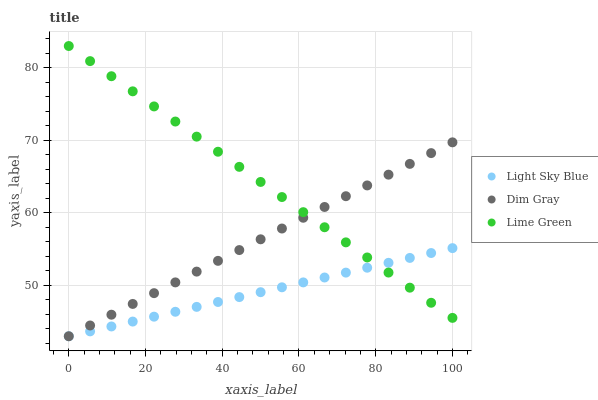Does Light Sky Blue have the minimum area under the curve?
Answer yes or no. Yes. Does Lime Green have the maximum area under the curve?
Answer yes or no. Yes. Does Lime Green have the minimum area under the curve?
Answer yes or no. No. Does Light Sky Blue have the maximum area under the curve?
Answer yes or no. No. Is Dim Gray the smoothest?
Answer yes or no. Yes. Is Lime Green the roughest?
Answer yes or no. Yes. Is Light Sky Blue the smoothest?
Answer yes or no. No. Is Light Sky Blue the roughest?
Answer yes or no. No. Does Dim Gray have the lowest value?
Answer yes or no. Yes. Does Lime Green have the lowest value?
Answer yes or no. No. Does Lime Green have the highest value?
Answer yes or no. Yes. Does Light Sky Blue have the highest value?
Answer yes or no. No. Does Lime Green intersect Light Sky Blue?
Answer yes or no. Yes. Is Lime Green less than Light Sky Blue?
Answer yes or no. No. Is Lime Green greater than Light Sky Blue?
Answer yes or no. No. 